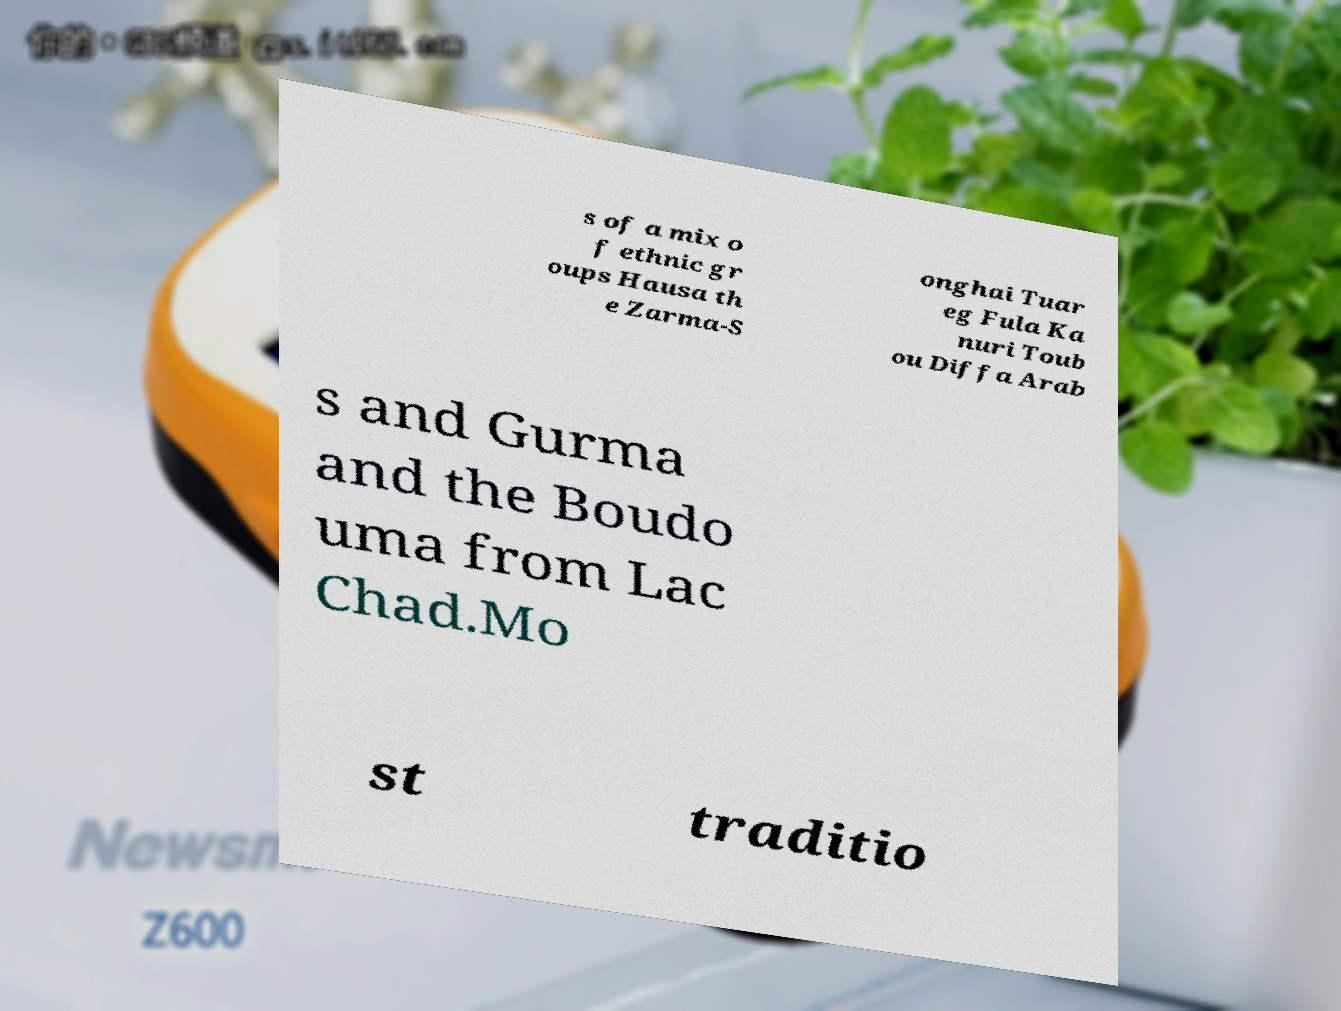Please identify and transcribe the text found in this image. s of a mix o f ethnic gr oups Hausa th e Zarma-S onghai Tuar eg Fula Ka nuri Toub ou Diffa Arab s and Gurma and the Boudo uma from Lac Chad.Mo st traditio 